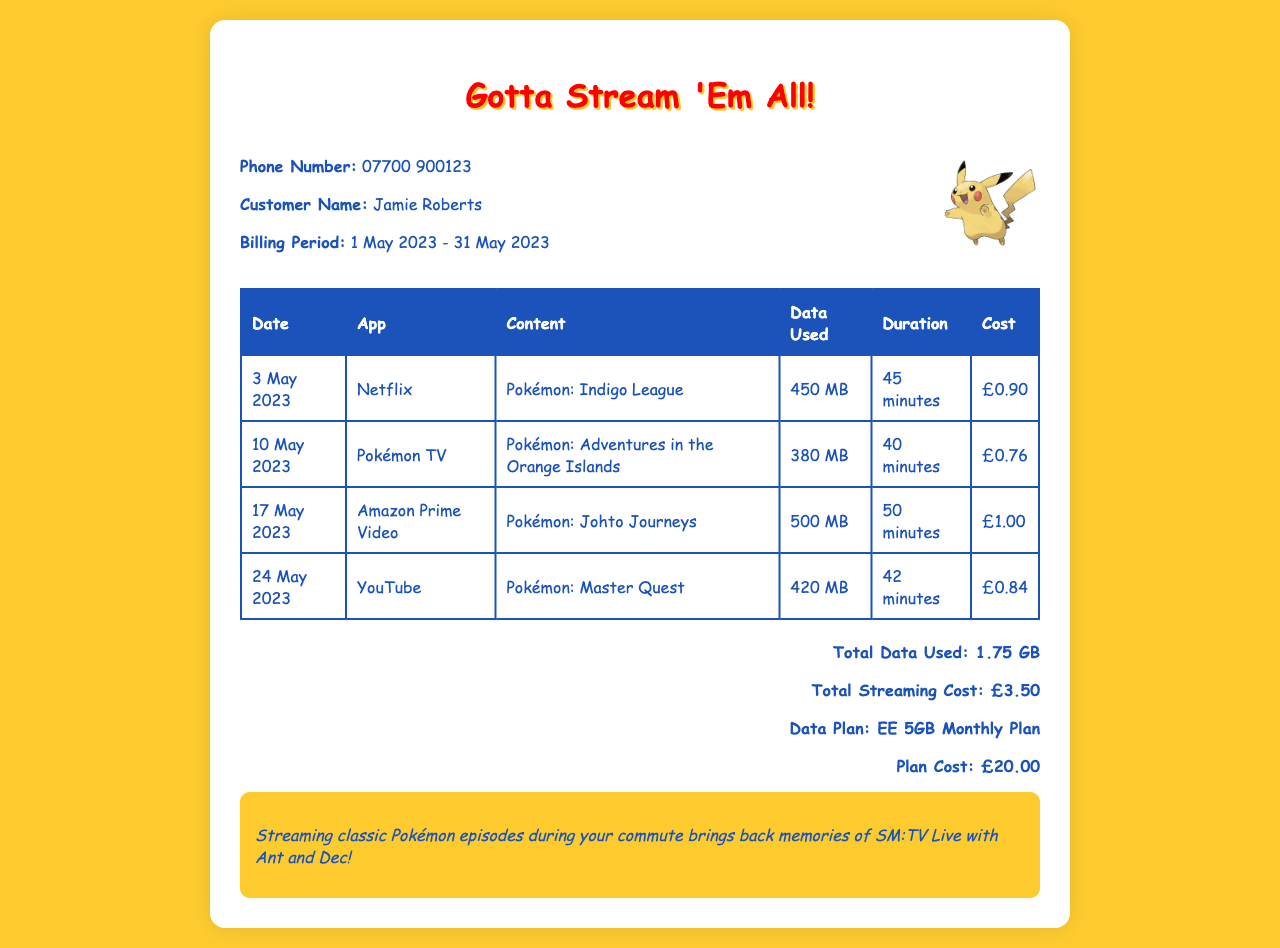What is the customer name? The customer name is located in the header section of the document.
Answer: Jamie Roberts What is the phone number? The phone number is listed in the header of the document.
Answer: 07700 900123 What is the total data used? The total data used is calculated from the individual data usage entries in the document.
Answer: 1.75 GB What was the longest streaming duration? The longest streaming duration can be determined from the duration column in the table.
Answer: 50 minutes What streaming service was used on 17 May 2023? The streaming service for that date is specified in the corresponding row of the table.
Answer: Amazon Prime Video What is the total streaming cost? The total streaming cost is presented in the summary section of the document.
Answer: £3.50 What is the billing period? The billing period is stated in the header section of the document.
Answer: 1 May 2023 - 31 May 2023 What content was streamed on 10 May 2023? The content streamed on that date can be found in the specified row of the table.
Answer: Pokémon: Adventures in the Orange Islands What is the data plan? The data plan is mentioned in the total summary section.
Answer: EE 5GB Monthly Plan What was the cost of the data plan? The cost of the data plan is presented in the total summary section.
Answer: £20.00 